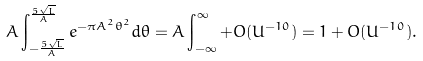<formula> <loc_0><loc_0><loc_500><loc_500>A \int _ { - \frac { 5 \sqrt { L } } { A } } ^ { \frac { 5 \sqrt { L } } { A } } e ^ { - \pi A ^ { 2 } \theta ^ { 2 } } d \theta = A \int _ { - \infty } ^ { \infty } + O ( U ^ { - 1 0 } ) = 1 + O ( U ^ { - 1 0 } ) .</formula> 